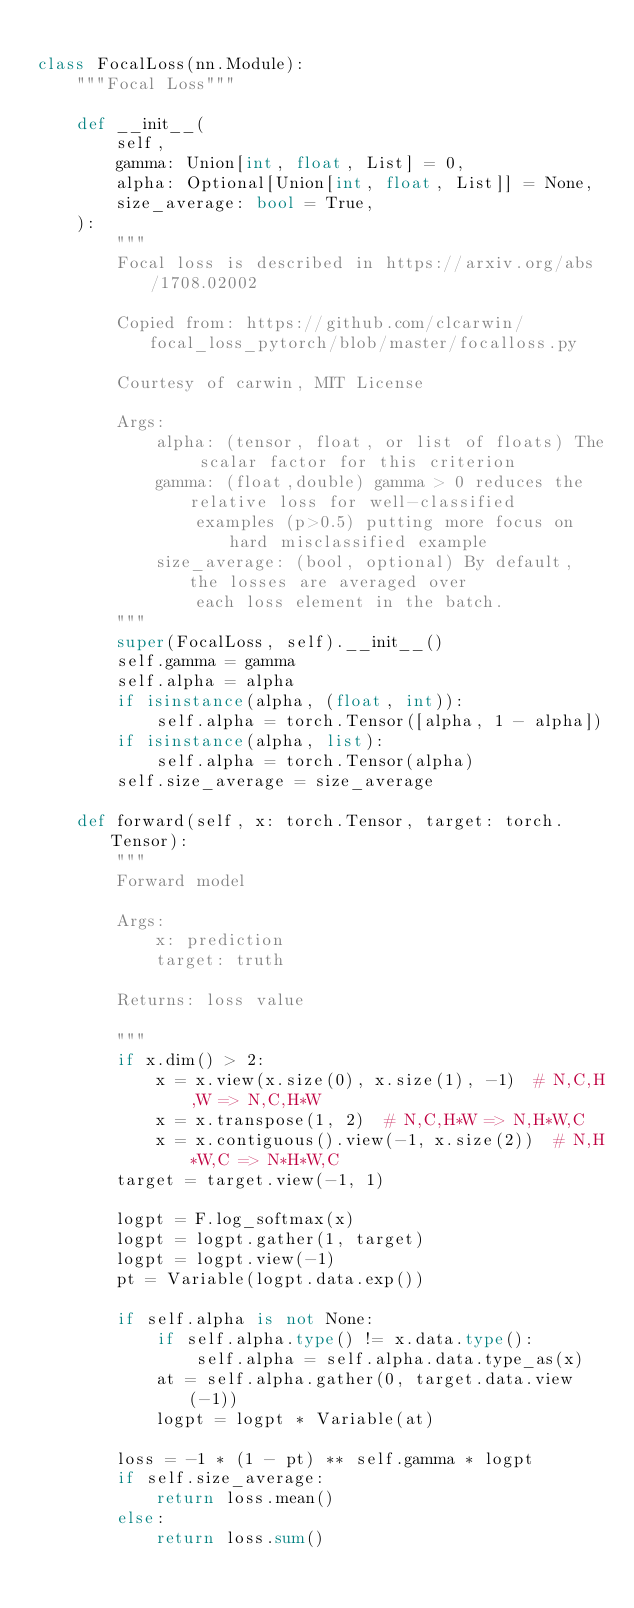<code> <loc_0><loc_0><loc_500><loc_500><_Python_>
class FocalLoss(nn.Module):
    """Focal Loss"""

    def __init__(
        self,
        gamma: Union[int, float, List] = 0,
        alpha: Optional[Union[int, float, List]] = None,
        size_average: bool = True,
    ):
        """
        Focal loss is described in https://arxiv.org/abs/1708.02002

        Copied from: https://github.com/clcarwin/focal_loss_pytorch/blob/master/focalloss.py

        Courtesy of carwin, MIT License

        Args:
            alpha: (tensor, float, or list of floats) The scalar factor for this criterion
            gamma: (float,double) gamma > 0 reduces the relative loss for well-classified
                examples (p>0.5) putting more focus on hard misclassified example
            size_average: (bool, optional) By default, the losses are averaged over
                each loss element in the batch.
        """
        super(FocalLoss, self).__init__()
        self.gamma = gamma
        self.alpha = alpha
        if isinstance(alpha, (float, int)):
            self.alpha = torch.Tensor([alpha, 1 - alpha])
        if isinstance(alpha, list):
            self.alpha = torch.Tensor(alpha)
        self.size_average = size_average

    def forward(self, x: torch.Tensor, target: torch.Tensor):
        """
        Forward model

        Args:
            x: prediction
            target: truth

        Returns: loss value

        """
        if x.dim() > 2:
            x = x.view(x.size(0), x.size(1), -1)  # N,C,H,W => N,C,H*W
            x = x.transpose(1, 2)  # N,C,H*W => N,H*W,C
            x = x.contiguous().view(-1, x.size(2))  # N,H*W,C => N*H*W,C
        target = target.view(-1, 1)

        logpt = F.log_softmax(x)
        logpt = logpt.gather(1, target)
        logpt = logpt.view(-1)
        pt = Variable(logpt.data.exp())

        if self.alpha is not None:
            if self.alpha.type() != x.data.type():
                self.alpha = self.alpha.data.type_as(x)
            at = self.alpha.gather(0, target.data.view(-1))
            logpt = logpt * Variable(at)

        loss = -1 * (1 - pt) ** self.gamma * logpt
        if self.size_average:
            return loss.mean()
        else:
            return loss.sum()
</code> 